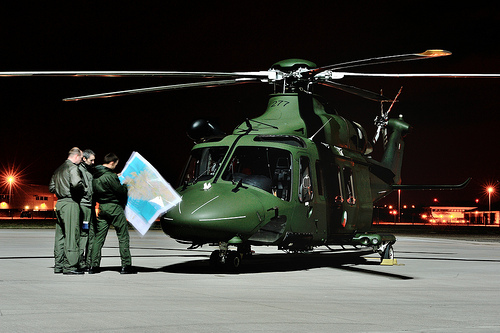<image>
Can you confirm if the blades is in the air? Yes. The blades is contained within or inside the air, showing a containment relationship. Is there a pilot in the helicopter? No. The pilot is not contained within the helicopter. These objects have a different spatial relationship. Is the helicopter behind the man? Yes. From this viewpoint, the helicopter is positioned behind the man, with the man partially or fully occluding the helicopter. 